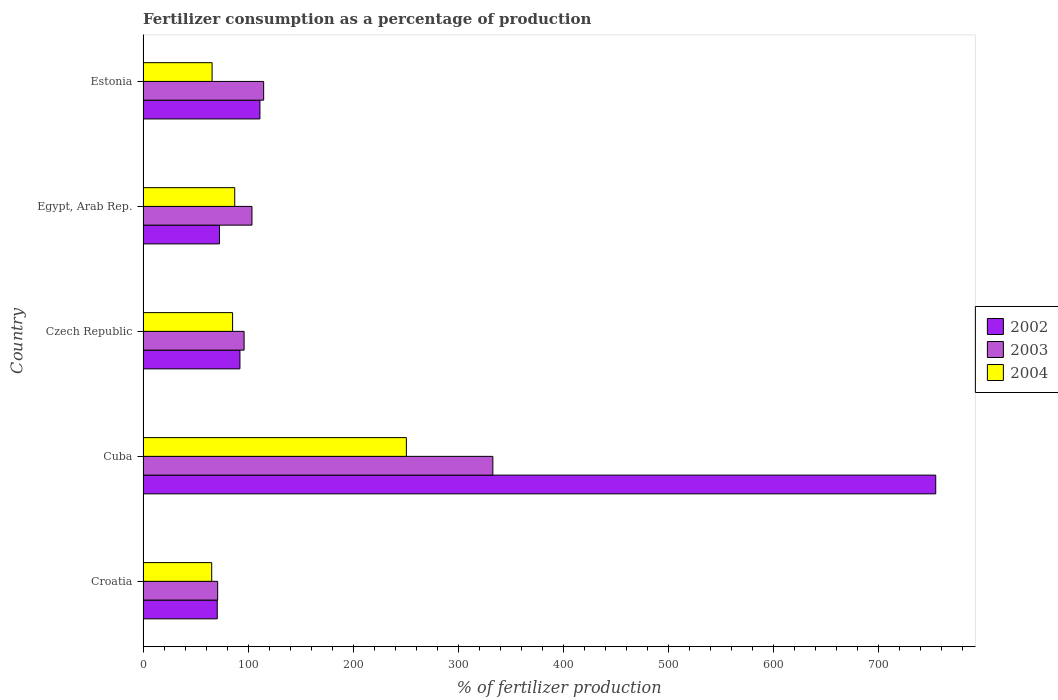How many different coloured bars are there?
Your answer should be very brief. 3. How many groups of bars are there?
Give a very brief answer. 5. Are the number of bars per tick equal to the number of legend labels?
Your answer should be very brief. Yes. Are the number of bars on each tick of the Y-axis equal?
Give a very brief answer. Yes. How many bars are there on the 1st tick from the top?
Offer a very short reply. 3. How many bars are there on the 1st tick from the bottom?
Offer a very short reply. 3. What is the label of the 3rd group of bars from the top?
Your response must be concise. Czech Republic. What is the percentage of fertilizers consumed in 2002 in Estonia?
Your answer should be compact. 111.3. Across all countries, what is the maximum percentage of fertilizers consumed in 2003?
Offer a very short reply. 333.13. Across all countries, what is the minimum percentage of fertilizers consumed in 2002?
Make the answer very short. 70.67. In which country was the percentage of fertilizers consumed in 2004 maximum?
Provide a succinct answer. Cuba. In which country was the percentage of fertilizers consumed in 2004 minimum?
Provide a short and direct response. Croatia. What is the total percentage of fertilizers consumed in 2004 in the graph?
Give a very brief answer. 554.46. What is the difference between the percentage of fertilizers consumed in 2002 in Cuba and that in Egypt, Arab Rep.?
Make the answer very short. 682.1. What is the difference between the percentage of fertilizers consumed in 2004 in Estonia and the percentage of fertilizers consumed in 2003 in Egypt, Arab Rep.?
Your answer should be compact. -37.98. What is the average percentage of fertilizers consumed in 2002 per country?
Your answer should be very brief. 220.39. What is the difference between the percentage of fertilizers consumed in 2003 and percentage of fertilizers consumed in 2004 in Croatia?
Your answer should be compact. 5.67. In how many countries, is the percentage of fertilizers consumed in 2004 greater than 300 %?
Give a very brief answer. 0. What is the ratio of the percentage of fertilizers consumed in 2004 in Czech Republic to that in Estonia?
Give a very brief answer. 1.3. What is the difference between the highest and the second highest percentage of fertilizers consumed in 2003?
Offer a very short reply. 218.28. What is the difference between the highest and the lowest percentage of fertilizers consumed in 2002?
Your answer should be very brief. 684.23. In how many countries, is the percentage of fertilizers consumed in 2003 greater than the average percentage of fertilizers consumed in 2003 taken over all countries?
Ensure brevity in your answer.  1. What does the 3rd bar from the top in Estonia represents?
Your answer should be very brief. 2002. What does the 2nd bar from the bottom in Cuba represents?
Your answer should be very brief. 2003. Is it the case that in every country, the sum of the percentage of fertilizers consumed in 2003 and percentage of fertilizers consumed in 2002 is greater than the percentage of fertilizers consumed in 2004?
Your response must be concise. Yes. How many bars are there?
Your answer should be very brief. 15. Are all the bars in the graph horizontal?
Your answer should be very brief. Yes. How many countries are there in the graph?
Provide a short and direct response. 5. What is the difference between two consecutive major ticks on the X-axis?
Provide a short and direct response. 100. Are the values on the major ticks of X-axis written in scientific E-notation?
Your answer should be very brief. No. Does the graph contain grids?
Keep it short and to the point. No. Where does the legend appear in the graph?
Your answer should be very brief. Center right. How are the legend labels stacked?
Provide a short and direct response. Vertical. What is the title of the graph?
Give a very brief answer. Fertilizer consumption as a percentage of production. What is the label or title of the X-axis?
Provide a short and direct response. % of fertilizer production. What is the label or title of the Y-axis?
Give a very brief answer. Country. What is the % of fertilizer production of 2002 in Croatia?
Your answer should be compact. 70.67. What is the % of fertilizer production in 2003 in Croatia?
Your response must be concise. 71.05. What is the % of fertilizer production in 2004 in Croatia?
Your answer should be very brief. 65.37. What is the % of fertilizer production in 2002 in Cuba?
Offer a terse response. 754.9. What is the % of fertilizer production in 2003 in Cuba?
Ensure brevity in your answer.  333.13. What is the % of fertilizer production in 2004 in Cuba?
Offer a terse response. 250.78. What is the % of fertilizer production in 2002 in Czech Republic?
Offer a very short reply. 92.26. What is the % of fertilizer production of 2003 in Czech Republic?
Keep it short and to the point. 96.22. What is the % of fertilizer production in 2004 in Czech Republic?
Offer a terse response. 85.27. What is the % of fertilizer production in 2002 in Egypt, Arab Rep.?
Your answer should be compact. 72.8. What is the % of fertilizer production of 2003 in Egypt, Arab Rep.?
Offer a very short reply. 103.72. What is the % of fertilizer production of 2004 in Egypt, Arab Rep.?
Provide a short and direct response. 87.3. What is the % of fertilizer production of 2002 in Estonia?
Make the answer very short. 111.3. What is the % of fertilizer production in 2003 in Estonia?
Make the answer very short. 114.85. What is the % of fertilizer production in 2004 in Estonia?
Ensure brevity in your answer.  65.74. Across all countries, what is the maximum % of fertilizer production of 2002?
Your answer should be very brief. 754.9. Across all countries, what is the maximum % of fertilizer production of 2003?
Provide a short and direct response. 333.13. Across all countries, what is the maximum % of fertilizer production of 2004?
Keep it short and to the point. 250.78. Across all countries, what is the minimum % of fertilizer production in 2002?
Make the answer very short. 70.67. Across all countries, what is the minimum % of fertilizer production in 2003?
Your answer should be very brief. 71.05. Across all countries, what is the minimum % of fertilizer production of 2004?
Offer a terse response. 65.37. What is the total % of fertilizer production in 2002 in the graph?
Your response must be concise. 1101.93. What is the total % of fertilizer production of 2003 in the graph?
Keep it short and to the point. 718.96. What is the total % of fertilizer production of 2004 in the graph?
Ensure brevity in your answer.  554.46. What is the difference between the % of fertilizer production of 2002 in Croatia and that in Cuba?
Keep it short and to the point. -684.23. What is the difference between the % of fertilizer production in 2003 in Croatia and that in Cuba?
Ensure brevity in your answer.  -262.08. What is the difference between the % of fertilizer production in 2004 in Croatia and that in Cuba?
Provide a succinct answer. -185.4. What is the difference between the % of fertilizer production in 2002 in Croatia and that in Czech Republic?
Provide a short and direct response. -21.59. What is the difference between the % of fertilizer production of 2003 in Croatia and that in Czech Republic?
Ensure brevity in your answer.  -25.17. What is the difference between the % of fertilizer production of 2004 in Croatia and that in Czech Republic?
Your answer should be compact. -19.89. What is the difference between the % of fertilizer production of 2002 in Croatia and that in Egypt, Arab Rep.?
Your response must be concise. -2.12. What is the difference between the % of fertilizer production of 2003 in Croatia and that in Egypt, Arab Rep.?
Your answer should be very brief. -32.67. What is the difference between the % of fertilizer production of 2004 in Croatia and that in Egypt, Arab Rep.?
Your answer should be compact. -21.92. What is the difference between the % of fertilizer production in 2002 in Croatia and that in Estonia?
Your answer should be compact. -40.63. What is the difference between the % of fertilizer production in 2003 in Croatia and that in Estonia?
Make the answer very short. -43.8. What is the difference between the % of fertilizer production of 2004 in Croatia and that in Estonia?
Your response must be concise. -0.36. What is the difference between the % of fertilizer production in 2002 in Cuba and that in Czech Republic?
Your answer should be very brief. 662.64. What is the difference between the % of fertilizer production in 2003 in Cuba and that in Czech Republic?
Provide a succinct answer. 236.9. What is the difference between the % of fertilizer production in 2004 in Cuba and that in Czech Republic?
Ensure brevity in your answer.  165.51. What is the difference between the % of fertilizer production of 2002 in Cuba and that in Egypt, Arab Rep.?
Ensure brevity in your answer.  682.1. What is the difference between the % of fertilizer production in 2003 in Cuba and that in Egypt, Arab Rep.?
Your response must be concise. 229.41. What is the difference between the % of fertilizer production of 2004 in Cuba and that in Egypt, Arab Rep.?
Keep it short and to the point. 163.48. What is the difference between the % of fertilizer production in 2002 in Cuba and that in Estonia?
Offer a terse response. 643.6. What is the difference between the % of fertilizer production in 2003 in Cuba and that in Estonia?
Give a very brief answer. 218.28. What is the difference between the % of fertilizer production of 2004 in Cuba and that in Estonia?
Offer a terse response. 185.04. What is the difference between the % of fertilizer production in 2002 in Czech Republic and that in Egypt, Arab Rep.?
Provide a short and direct response. 19.47. What is the difference between the % of fertilizer production of 2003 in Czech Republic and that in Egypt, Arab Rep.?
Your response must be concise. -7.5. What is the difference between the % of fertilizer production of 2004 in Czech Republic and that in Egypt, Arab Rep.?
Make the answer very short. -2.03. What is the difference between the % of fertilizer production in 2002 in Czech Republic and that in Estonia?
Keep it short and to the point. -19.04. What is the difference between the % of fertilizer production of 2003 in Czech Republic and that in Estonia?
Provide a succinct answer. -18.63. What is the difference between the % of fertilizer production in 2004 in Czech Republic and that in Estonia?
Provide a short and direct response. 19.53. What is the difference between the % of fertilizer production in 2002 in Egypt, Arab Rep. and that in Estonia?
Your response must be concise. -38.51. What is the difference between the % of fertilizer production in 2003 in Egypt, Arab Rep. and that in Estonia?
Provide a short and direct response. -11.13. What is the difference between the % of fertilizer production of 2004 in Egypt, Arab Rep. and that in Estonia?
Your answer should be compact. 21.56. What is the difference between the % of fertilizer production in 2002 in Croatia and the % of fertilizer production in 2003 in Cuba?
Your answer should be very brief. -262.45. What is the difference between the % of fertilizer production of 2002 in Croatia and the % of fertilizer production of 2004 in Cuba?
Your response must be concise. -180.11. What is the difference between the % of fertilizer production in 2003 in Croatia and the % of fertilizer production in 2004 in Cuba?
Keep it short and to the point. -179.73. What is the difference between the % of fertilizer production in 2002 in Croatia and the % of fertilizer production in 2003 in Czech Republic?
Make the answer very short. -25.55. What is the difference between the % of fertilizer production in 2002 in Croatia and the % of fertilizer production in 2004 in Czech Republic?
Your response must be concise. -14.6. What is the difference between the % of fertilizer production in 2003 in Croatia and the % of fertilizer production in 2004 in Czech Republic?
Your answer should be compact. -14.22. What is the difference between the % of fertilizer production in 2002 in Croatia and the % of fertilizer production in 2003 in Egypt, Arab Rep.?
Keep it short and to the point. -33.05. What is the difference between the % of fertilizer production in 2002 in Croatia and the % of fertilizer production in 2004 in Egypt, Arab Rep.?
Give a very brief answer. -16.63. What is the difference between the % of fertilizer production in 2003 in Croatia and the % of fertilizer production in 2004 in Egypt, Arab Rep.?
Offer a terse response. -16.25. What is the difference between the % of fertilizer production of 2002 in Croatia and the % of fertilizer production of 2003 in Estonia?
Give a very brief answer. -44.18. What is the difference between the % of fertilizer production of 2002 in Croatia and the % of fertilizer production of 2004 in Estonia?
Ensure brevity in your answer.  4.93. What is the difference between the % of fertilizer production of 2003 in Croatia and the % of fertilizer production of 2004 in Estonia?
Your answer should be compact. 5.31. What is the difference between the % of fertilizer production in 2002 in Cuba and the % of fertilizer production in 2003 in Czech Republic?
Provide a succinct answer. 658.68. What is the difference between the % of fertilizer production in 2002 in Cuba and the % of fertilizer production in 2004 in Czech Republic?
Your answer should be very brief. 669.63. What is the difference between the % of fertilizer production in 2003 in Cuba and the % of fertilizer production in 2004 in Czech Republic?
Provide a short and direct response. 247.86. What is the difference between the % of fertilizer production of 2002 in Cuba and the % of fertilizer production of 2003 in Egypt, Arab Rep.?
Ensure brevity in your answer.  651.18. What is the difference between the % of fertilizer production in 2002 in Cuba and the % of fertilizer production in 2004 in Egypt, Arab Rep.?
Make the answer very short. 667.6. What is the difference between the % of fertilizer production of 2003 in Cuba and the % of fertilizer production of 2004 in Egypt, Arab Rep.?
Offer a very short reply. 245.83. What is the difference between the % of fertilizer production of 2002 in Cuba and the % of fertilizer production of 2003 in Estonia?
Your answer should be very brief. 640.05. What is the difference between the % of fertilizer production in 2002 in Cuba and the % of fertilizer production in 2004 in Estonia?
Offer a very short reply. 689.16. What is the difference between the % of fertilizer production of 2003 in Cuba and the % of fertilizer production of 2004 in Estonia?
Make the answer very short. 267.39. What is the difference between the % of fertilizer production of 2002 in Czech Republic and the % of fertilizer production of 2003 in Egypt, Arab Rep.?
Your response must be concise. -11.46. What is the difference between the % of fertilizer production of 2002 in Czech Republic and the % of fertilizer production of 2004 in Egypt, Arab Rep.?
Offer a very short reply. 4.96. What is the difference between the % of fertilizer production in 2003 in Czech Republic and the % of fertilizer production in 2004 in Egypt, Arab Rep.?
Your answer should be very brief. 8.92. What is the difference between the % of fertilizer production in 2002 in Czech Republic and the % of fertilizer production in 2003 in Estonia?
Your answer should be compact. -22.59. What is the difference between the % of fertilizer production in 2002 in Czech Republic and the % of fertilizer production in 2004 in Estonia?
Your response must be concise. 26.52. What is the difference between the % of fertilizer production in 2003 in Czech Republic and the % of fertilizer production in 2004 in Estonia?
Give a very brief answer. 30.48. What is the difference between the % of fertilizer production in 2002 in Egypt, Arab Rep. and the % of fertilizer production in 2003 in Estonia?
Offer a very short reply. -42.05. What is the difference between the % of fertilizer production of 2002 in Egypt, Arab Rep. and the % of fertilizer production of 2004 in Estonia?
Make the answer very short. 7.06. What is the difference between the % of fertilizer production of 2003 in Egypt, Arab Rep. and the % of fertilizer production of 2004 in Estonia?
Your answer should be very brief. 37.98. What is the average % of fertilizer production in 2002 per country?
Keep it short and to the point. 220.39. What is the average % of fertilizer production of 2003 per country?
Give a very brief answer. 143.79. What is the average % of fertilizer production of 2004 per country?
Provide a succinct answer. 110.89. What is the difference between the % of fertilizer production of 2002 and % of fertilizer production of 2003 in Croatia?
Your response must be concise. -0.38. What is the difference between the % of fertilizer production of 2002 and % of fertilizer production of 2004 in Croatia?
Make the answer very short. 5.3. What is the difference between the % of fertilizer production in 2003 and % of fertilizer production in 2004 in Croatia?
Your answer should be very brief. 5.67. What is the difference between the % of fertilizer production in 2002 and % of fertilizer production in 2003 in Cuba?
Offer a terse response. 421.78. What is the difference between the % of fertilizer production in 2002 and % of fertilizer production in 2004 in Cuba?
Offer a terse response. 504.12. What is the difference between the % of fertilizer production of 2003 and % of fertilizer production of 2004 in Cuba?
Give a very brief answer. 82.35. What is the difference between the % of fertilizer production in 2002 and % of fertilizer production in 2003 in Czech Republic?
Ensure brevity in your answer.  -3.96. What is the difference between the % of fertilizer production of 2002 and % of fertilizer production of 2004 in Czech Republic?
Your answer should be very brief. 6.99. What is the difference between the % of fertilizer production of 2003 and % of fertilizer production of 2004 in Czech Republic?
Make the answer very short. 10.95. What is the difference between the % of fertilizer production of 2002 and % of fertilizer production of 2003 in Egypt, Arab Rep.?
Give a very brief answer. -30.92. What is the difference between the % of fertilizer production of 2002 and % of fertilizer production of 2004 in Egypt, Arab Rep.?
Offer a very short reply. -14.5. What is the difference between the % of fertilizer production of 2003 and % of fertilizer production of 2004 in Egypt, Arab Rep.?
Your answer should be very brief. 16.42. What is the difference between the % of fertilizer production in 2002 and % of fertilizer production in 2003 in Estonia?
Offer a terse response. -3.55. What is the difference between the % of fertilizer production in 2002 and % of fertilizer production in 2004 in Estonia?
Offer a very short reply. 45.57. What is the difference between the % of fertilizer production in 2003 and % of fertilizer production in 2004 in Estonia?
Offer a terse response. 49.11. What is the ratio of the % of fertilizer production of 2002 in Croatia to that in Cuba?
Give a very brief answer. 0.09. What is the ratio of the % of fertilizer production of 2003 in Croatia to that in Cuba?
Ensure brevity in your answer.  0.21. What is the ratio of the % of fertilizer production in 2004 in Croatia to that in Cuba?
Provide a succinct answer. 0.26. What is the ratio of the % of fertilizer production in 2002 in Croatia to that in Czech Republic?
Your answer should be very brief. 0.77. What is the ratio of the % of fertilizer production in 2003 in Croatia to that in Czech Republic?
Your answer should be very brief. 0.74. What is the ratio of the % of fertilizer production of 2004 in Croatia to that in Czech Republic?
Give a very brief answer. 0.77. What is the ratio of the % of fertilizer production in 2002 in Croatia to that in Egypt, Arab Rep.?
Give a very brief answer. 0.97. What is the ratio of the % of fertilizer production of 2003 in Croatia to that in Egypt, Arab Rep.?
Offer a terse response. 0.69. What is the ratio of the % of fertilizer production in 2004 in Croatia to that in Egypt, Arab Rep.?
Keep it short and to the point. 0.75. What is the ratio of the % of fertilizer production in 2002 in Croatia to that in Estonia?
Keep it short and to the point. 0.63. What is the ratio of the % of fertilizer production in 2003 in Croatia to that in Estonia?
Offer a terse response. 0.62. What is the ratio of the % of fertilizer production in 2004 in Croatia to that in Estonia?
Keep it short and to the point. 0.99. What is the ratio of the % of fertilizer production of 2002 in Cuba to that in Czech Republic?
Offer a very short reply. 8.18. What is the ratio of the % of fertilizer production of 2003 in Cuba to that in Czech Republic?
Provide a short and direct response. 3.46. What is the ratio of the % of fertilizer production of 2004 in Cuba to that in Czech Republic?
Keep it short and to the point. 2.94. What is the ratio of the % of fertilizer production in 2002 in Cuba to that in Egypt, Arab Rep.?
Your answer should be very brief. 10.37. What is the ratio of the % of fertilizer production in 2003 in Cuba to that in Egypt, Arab Rep.?
Provide a succinct answer. 3.21. What is the ratio of the % of fertilizer production in 2004 in Cuba to that in Egypt, Arab Rep.?
Provide a short and direct response. 2.87. What is the ratio of the % of fertilizer production in 2002 in Cuba to that in Estonia?
Ensure brevity in your answer.  6.78. What is the ratio of the % of fertilizer production of 2003 in Cuba to that in Estonia?
Keep it short and to the point. 2.9. What is the ratio of the % of fertilizer production in 2004 in Cuba to that in Estonia?
Your response must be concise. 3.81. What is the ratio of the % of fertilizer production of 2002 in Czech Republic to that in Egypt, Arab Rep.?
Give a very brief answer. 1.27. What is the ratio of the % of fertilizer production of 2003 in Czech Republic to that in Egypt, Arab Rep.?
Your answer should be very brief. 0.93. What is the ratio of the % of fertilizer production in 2004 in Czech Republic to that in Egypt, Arab Rep.?
Make the answer very short. 0.98. What is the ratio of the % of fertilizer production in 2002 in Czech Republic to that in Estonia?
Make the answer very short. 0.83. What is the ratio of the % of fertilizer production of 2003 in Czech Republic to that in Estonia?
Give a very brief answer. 0.84. What is the ratio of the % of fertilizer production in 2004 in Czech Republic to that in Estonia?
Offer a terse response. 1.3. What is the ratio of the % of fertilizer production of 2002 in Egypt, Arab Rep. to that in Estonia?
Your response must be concise. 0.65. What is the ratio of the % of fertilizer production of 2003 in Egypt, Arab Rep. to that in Estonia?
Your response must be concise. 0.9. What is the ratio of the % of fertilizer production of 2004 in Egypt, Arab Rep. to that in Estonia?
Give a very brief answer. 1.33. What is the difference between the highest and the second highest % of fertilizer production of 2002?
Your response must be concise. 643.6. What is the difference between the highest and the second highest % of fertilizer production of 2003?
Your answer should be compact. 218.28. What is the difference between the highest and the second highest % of fertilizer production in 2004?
Offer a very short reply. 163.48. What is the difference between the highest and the lowest % of fertilizer production in 2002?
Keep it short and to the point. 684.23. What is the difference between the highest and the lowest % of fertilizer production of 2003?
Your response must be concise. 262.08. What is the difference between the highest and the lowest % of fertilizer production in 2004?
Make the answer very short. 185.4. 